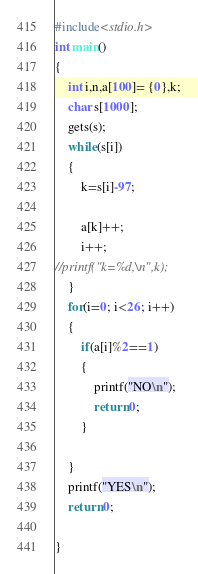Convert code to text. <code><loc_0><loc_0><loc_500><loc_500><_C_>#include<stdio.h>
int main()
{
    int i,n,a[100]= {0},k;
    char s[1000];
    gets(s);
    while(s[i])
    {
        k=s[i]-97;
        
        a[k]++;
        i++;
//printf("k=%d,\n",k);
    }
    for(i=0; i<26; i++)
    {
        if(a[i]%2==1)
        {
            printf("NO\n");
            return 0;
        }

    }
    printf("YES\n");
    return 0;

}
</code> 